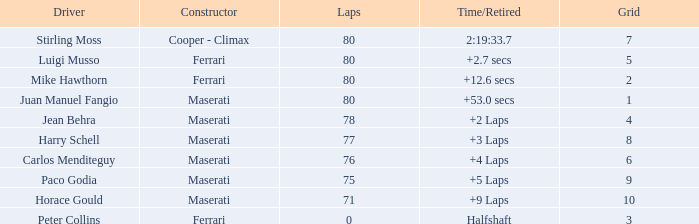What were the lowest laps of Luigi Musso driving a Ferrari with a Grid larger than 2? 80.0. 